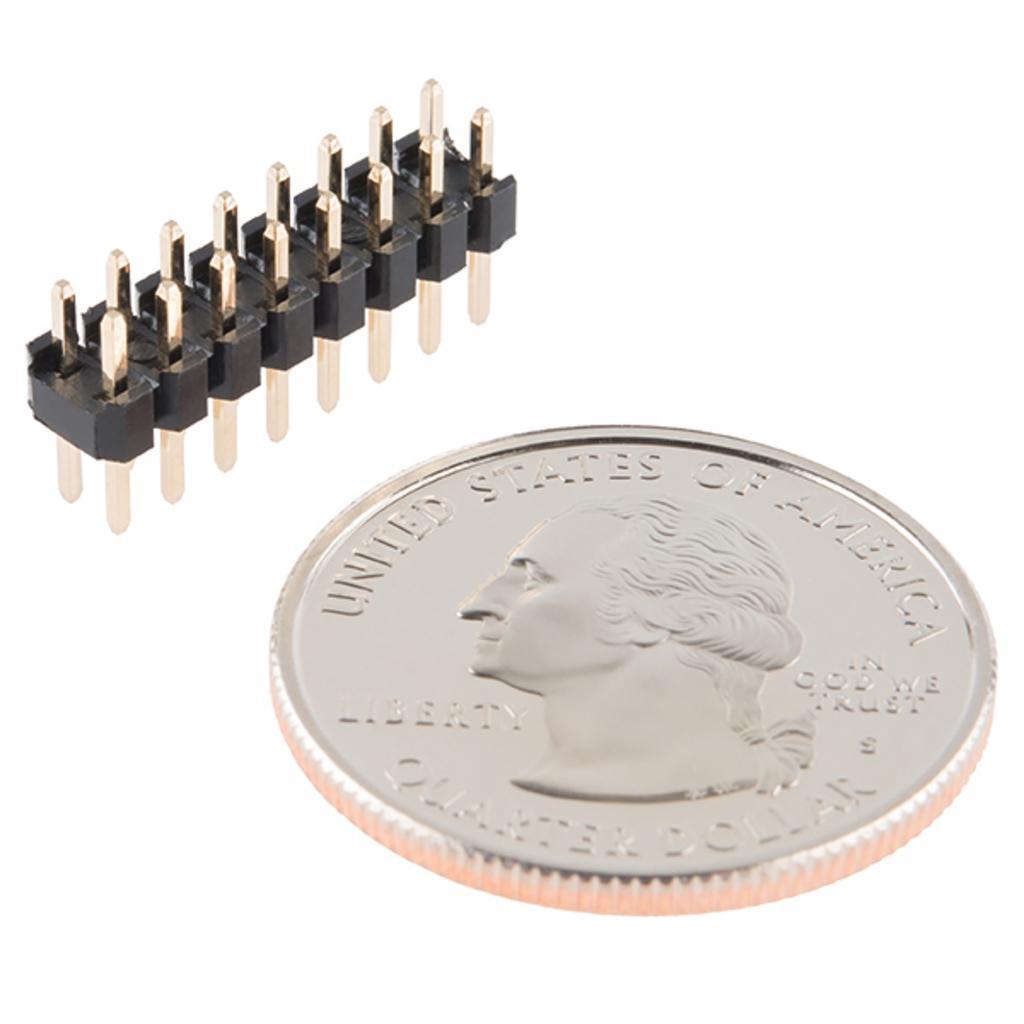Please provide a concise description of this image. In this picture there is a coin and there is a text and there is a picture of a person on the coin and there is an electric connector. At the back there is a white background. 